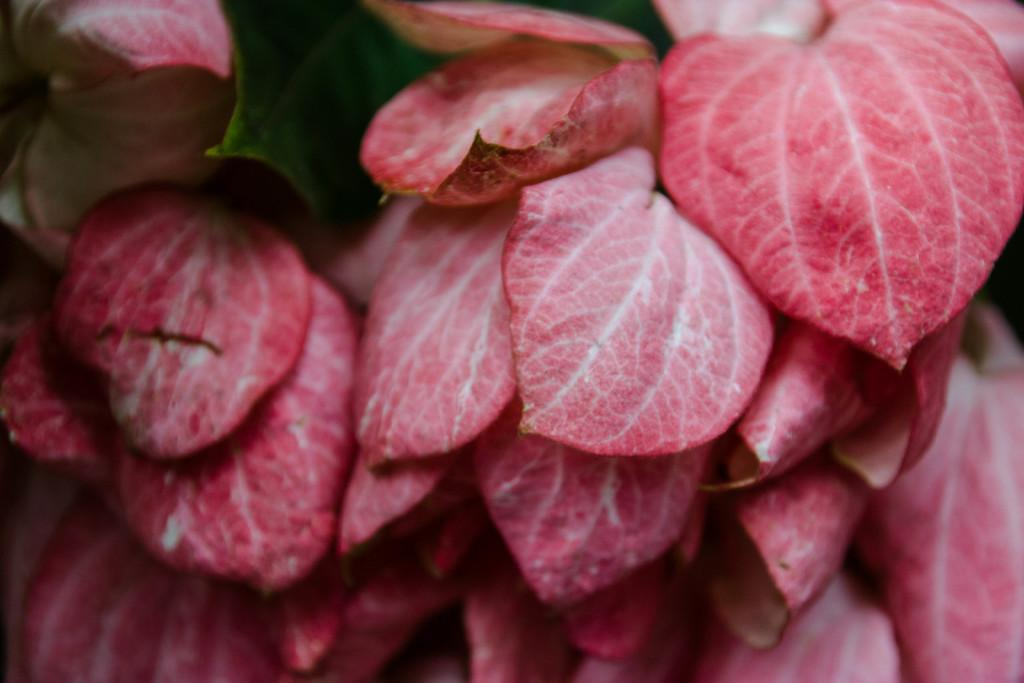What is the main subject of the image? The main subject of the image is a group of leaves. Can you describe the color of some of the leaves? Some of the leaves are red in color. Are there any other colors present in the leaves? Yes, there is a part of a green color leaf in the image. How many muscles can be seen in the image? There are no muscles present in the image; it features a group of leaves. What type of glass object is visible in the image? There is no glass object present in the image. 